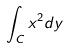<formula> <loc_0><loc_0><loc_500><loc_500>\int _ { C } x ^ { 2 } d y</formula> 